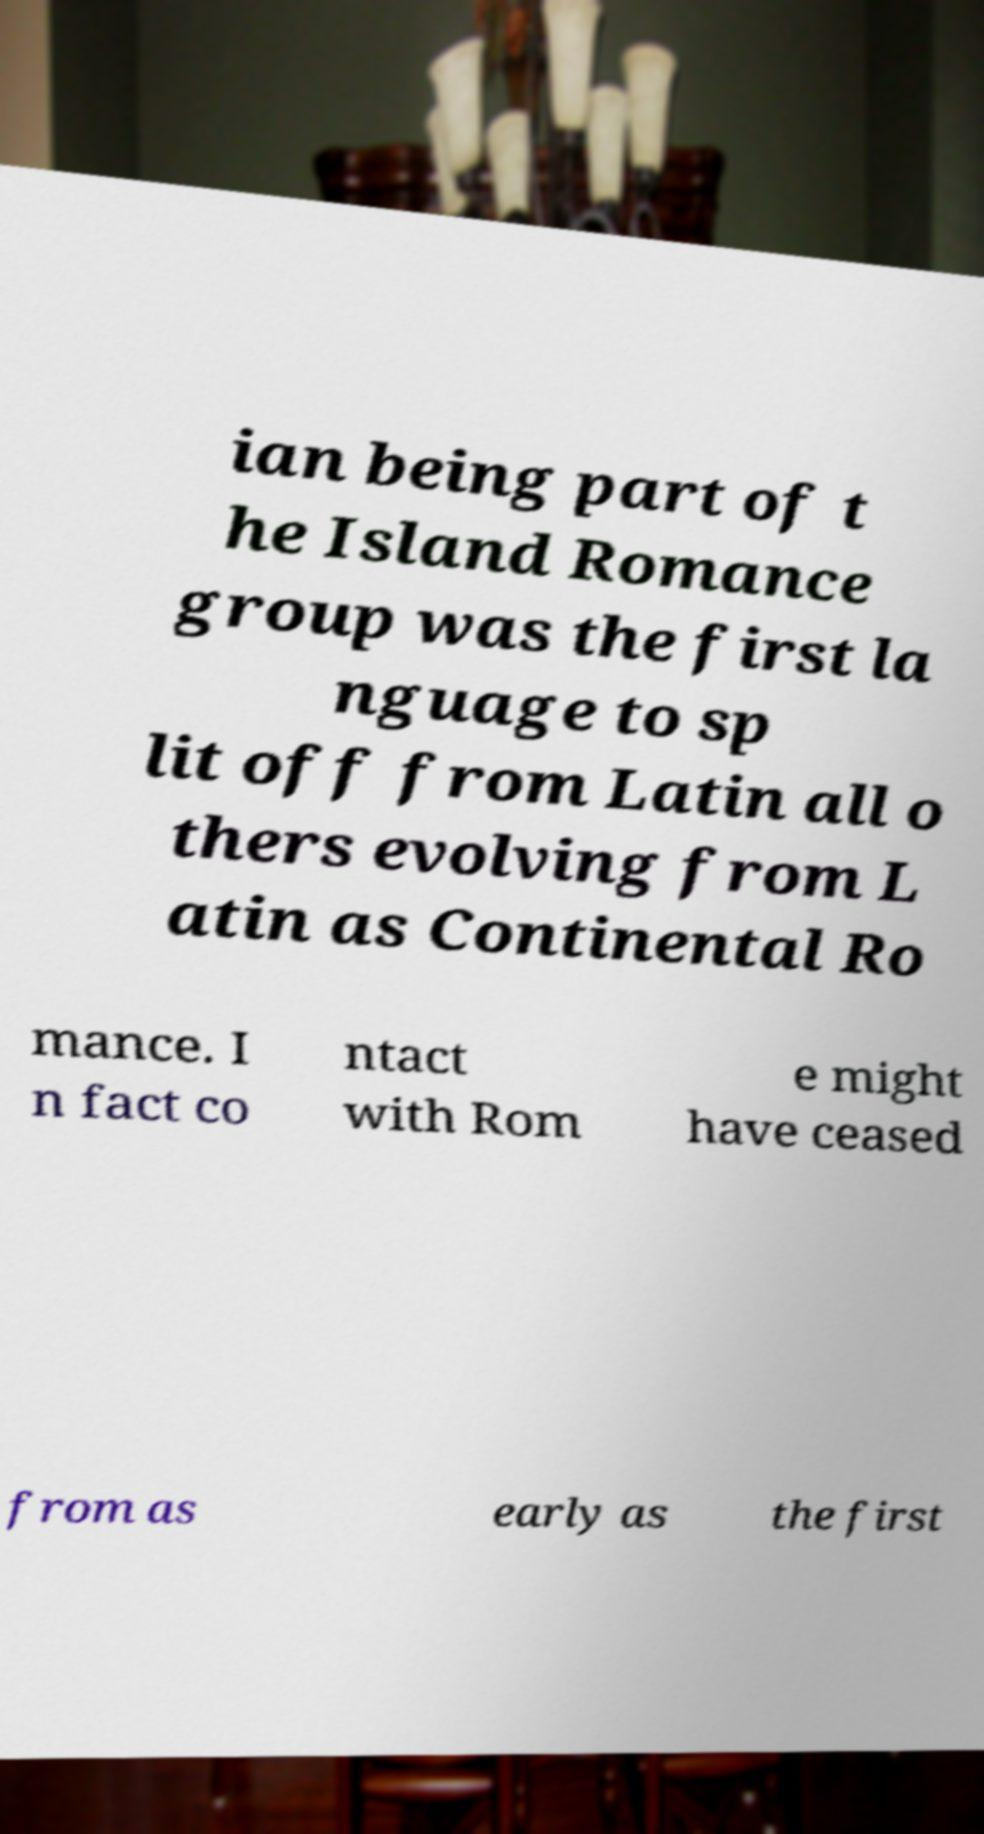I need the written content from this picture converted into text. Can you do that? ian being part of t he Island Romance group was the first la nguage to sp lit off from Latin all o thers evolving from L atin as Continental Ro mance. I n fact co ntact with Rom e might have ceased from as early as the first 